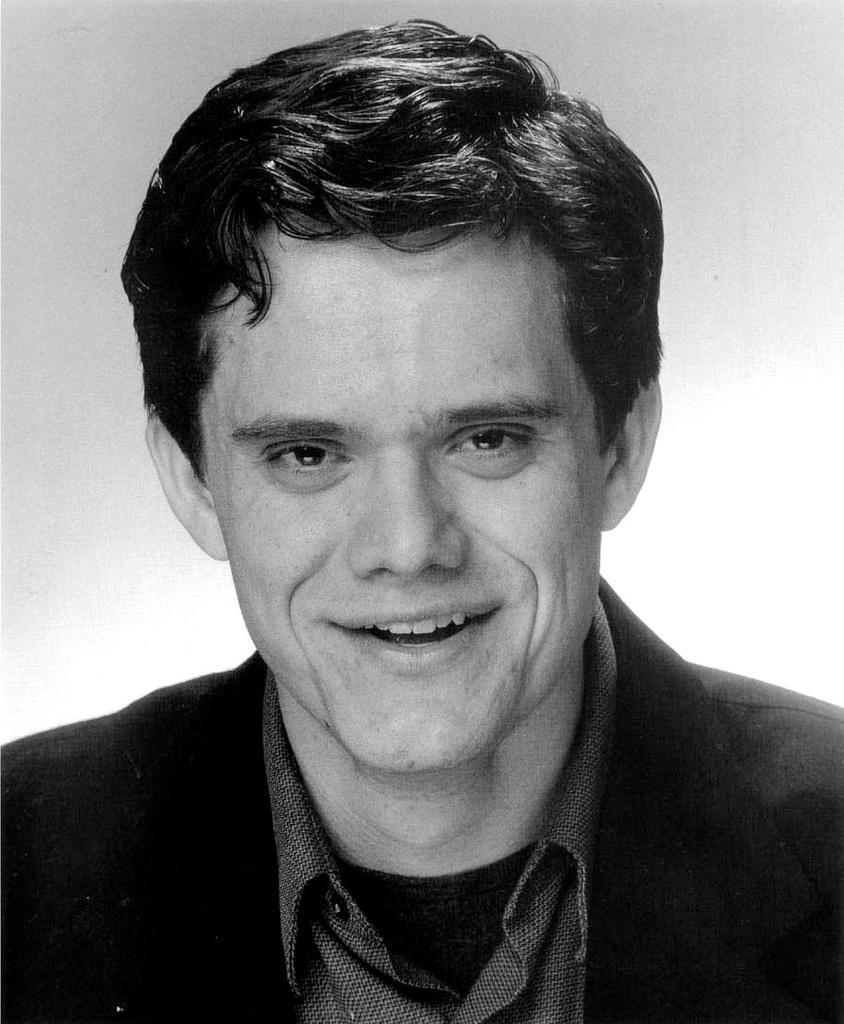Who is the main subject in the image? There is a man in the center of the image. What type of appliance is the man sitting on in the image? There is no appliance or sofa present in the image, as it only shows the man in the center. 